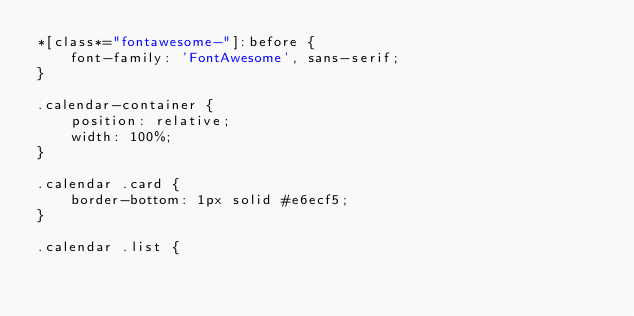Convert code to text. <code><loc_0><loc_0><loc_500><loc_500><_CSS_>*[class*="fontawesome-"]:before {
    font-family: 'FontAwesome', sans-serif;
}

.calendar-container {
    position: relative;
    width: 100%;
}

.calendar .card {
    border-bottom: 1px solid #e6ecf5;
}

.calendar .list {</code> 